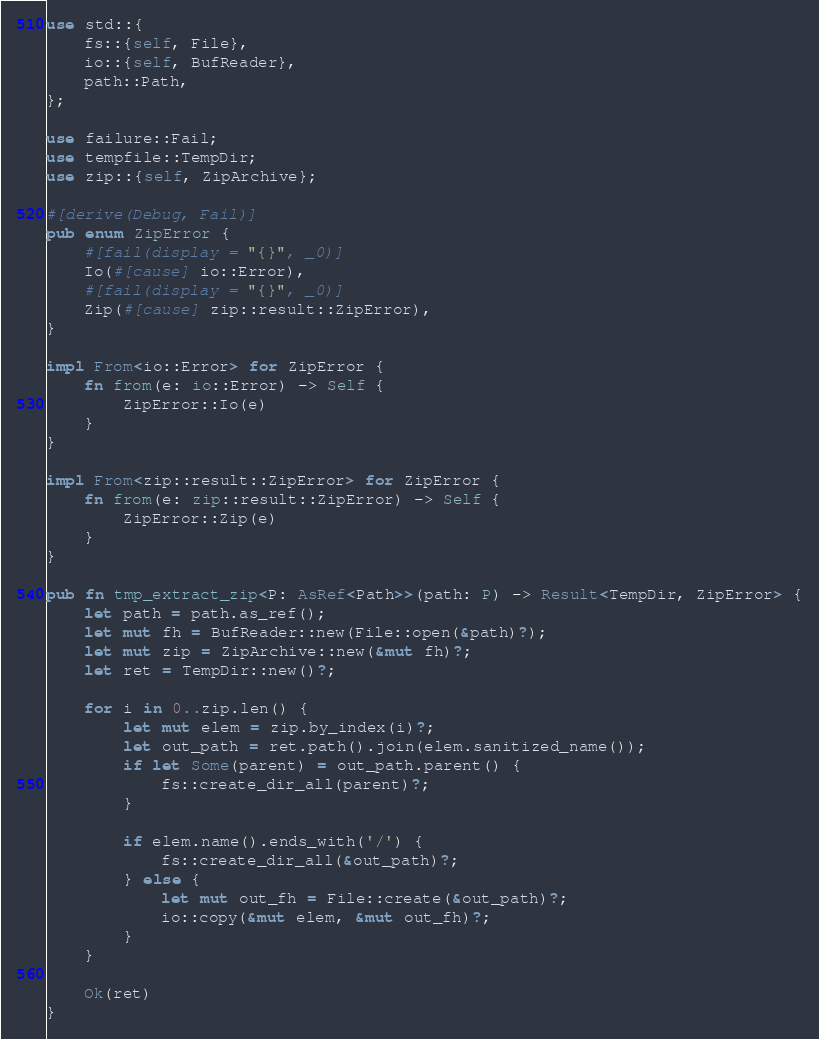<code> <loc_0><loc_0><loc_500><loc_500><_Rust_>use std::{
    fs::{self, File},
    io::{self, BufReader},
    path::Path,
};

use failure::Fail;
use tempfile::TempDir;
use zip::{self, ZipArchive};

#[derive(Debug, Fail)]
pub enum ZipError {
    #[fail(display = "{}", _0)]
    Io(#[cause] io::Error),
    #[fail(display = "{}", _0)]
    Zip(#[cause] zip::result::ZipError),
}

impl From<io::Error> for ZipError {
    fn from(e: io::Error) -> Self {
        ZipError::Io(e)
    }
}

impl From<zip::result::ZipError> for ZipError {
    fn from(e: zip::result::ZipError) -> Self {
        ZipError::Zip(e)
    }
}

pub fn tmp_extract_zip<P: AsRef<Path>>(path: P) -> Result<TempDir, ZipError> {
    let path = path.as_ref();
    let mut fh = BufReader::new(File::open(&path)?);
    let mut zip = ZipArchive::new(&mut fh)?;
    let ret = TempDir::new()?;

    for i in 0..zip.len() {
        let mut elem = zip.by_index(i)?;
        let out_path = ret.path().join(elem.sanitized_name());
        if let Some(parent) = out_path.parent() {
            fs::create_dir_all(parent)?;
        }

        if elem.name().ends_with('/') {
            fs::create_dir_all(&out_path)?;
        } else {
            let mut out_fh = File::create(&out_path)?;
            io::copy(&mut elem, &mut out_fh)?;
        }
    }

    Ok(ret)
}
</code> 